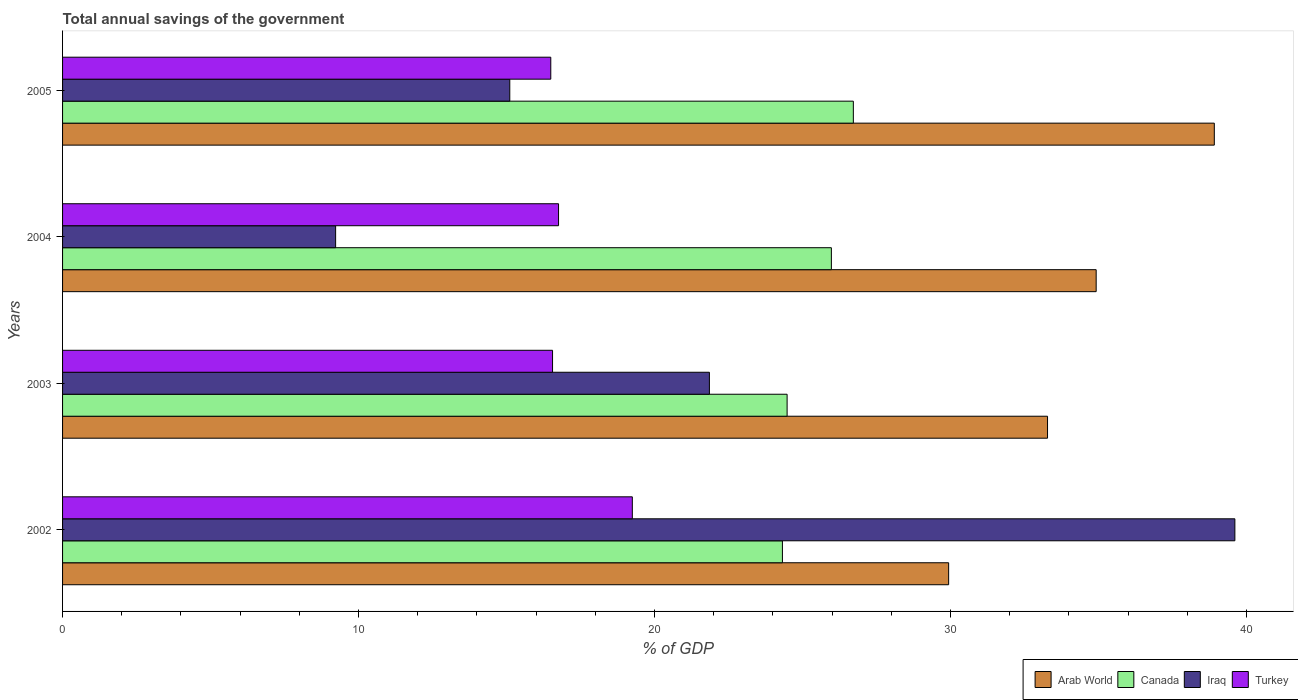How many bars are there on the 2nd tick from the bottom?
Keep it short and to the point. 4. What is the label of the 2nd group of bars from the top?
Your response must be concise. 2004. In how many cases, is the number of bars for a given year not equal to the number of legend labels?
Your response must be concise. 0. What is the total annual savings of the government in Iraq in 2005?
Provide a succinct answer. 15.11. Across all years, what is the maximum total annual savings of the government in Turkey?
Keep it short and to the point. 19.25. Across all years, what is the minimum total annual savings of the government in Iraq?
Ensure brevity in your answer.  9.22. In which year was the total annual savings of the government in Arab World maximum?
Your answer should be compact. 2005. In which year was the total annual savings of the government in Arab World minimum?
Make the answer very short. 2002. What is the total total annual savings of the government in Arab World in the graph?
Make the answer very short. 137.04. What is the difference between the total annual savings of the government in Iraq in 2004 and that in 2005?
Provide a succinct answer. -5.88. What is the difference between the total annual savings of the government in Canada in 2003 and the total annual savings of the government in Turkey in 2002?
Your response must be concise. 5.23. What is the average total annual savings of the government in Turkey per year?
Give a very brief answer. 17.26. In the year 2005, what is the difference between the total annual savings of the government in Arab World and total annual savings of the government in Canada?
Keep it short and to the point. 12.19. What is the ratio of the total annual savings of the government in Canada in 2002 to that in 2005?
Offer a terse response. 0.91. What is the difference between the highest and the second highest total annual savings of the government in Turkey?
Keep it short and to the point. 2.49. What is the difference between the highest and the lowest total annual savings of the government in Canada?
Your answer should be very brief. 2.4. In how many years, is the total annual savings of the government in Canada greater than the average total annual savings of the government in Canada taken over all years?
Provide a short and direct response. 2. Is the sum of the total annual savings of the government in Canada in 2003 and 2005 greater than the maximum total annual savings of the government in Turkey across all years?
Your response must be concise. Yes. Is it the case that in every year, the sum of the total annual savings of the government in Canada and total annual savings of the government in Iraq is greater than the sum of total annual savings of the government in Turkey and total annual savings of the government in Arab World?
Ensure brevity in your answer.  No. What does the 4th bar from the top in 2005 represents?
Offer a very short reply. Arab World. What does the 1st bar from the bottom in 2004 represents?
Your response must be concise. Arab World. Is it the case that in every year, the sum of the total annual savings of the government in Iraq and total annual savings of the government in Canada is greater than the total annual savings of the government in Arab World?
Keep it short and to the point. Yes. How many bars are there?
Offer a very short reply. 16. How many years are there in the graph?
Offer a terse response. 4. Are the values on the major ticks of X-axis written in scientific E-notation?
Make the answer very short. No. Does the graph contain any zero values?
Your response must be concise. No. Does the graph contain grids?
Your answer should be very brief. No. Where does the legend appear in the graph?
Make the answer very short. Bottom right. How many legend labels are there?
Your response must be concise. 4. What is the title of the graph?
Provide a succinct answer. Total annual savings of the government. What is the label or title of the X-axis?
Your response must be concise. % of GDP. What is the % of GDP of Arab World in 2002?
Your response must be concise. 29.93. What is the % of GDP in Canada in 2002?
Ensure brevity in your answer.  24.32. What is the % of GDP in Iraq in 2002?
Your answer should be compact. 39.6. What is the % of GDP of Turkey in 2002?
Make the answer very short. 19.25. What is the % of GDP in Arab World in 2003?
Your answer should be very brief. 33.28. What is the % of GDP in Canada in 2003?
Offer a terse response. 24.48. What is the % of GDP of Iraq in 2003?
Give a very brief answer. 21.85. What is the % of GDP of Turkey in 2003?
Make the answer very short. 16.55. What is the % of GDP of Arab World in 2004?
Keep it short and to the point. 34.92. What is the % of GDP in Canada in 2004?
Keep it short and to the point. 25.97. What is the % of GDP of Iraq in 2004?
Ensure brevity in your answer.  9.22. What is the % of GDP in Turkey in 2004?
Your answer should be very brief. 16.76. What is the % of GDP of Arab World in 2005?
Give a very brief answer. 38.91. What is the % of GDP of Canada in 2005?
Keep it short and to the point. 26.72. What is the % of GDP in Iraq in 2005?
Give a very brief answer. 15.11. What is the % of GDP in Turkey in 2005?
Your answer should be very brief. 16.49. Across all years, what is the maximum % of GDP of Arab World?
Your answer should be very brief. 38.91. Across all years, what is the maximum % of GDP of Canada?
Your response must be concise. 26.72. Across all years, what is the maximum % of GDP of Iraq?
Keep it short and to the point. 39.6. Across all years, what is the maximum % of GDP of Turkey?
Keep it short and to the point. 19.25. Across all years, what is the minimum % of GDP in Arab World?
Make the answer very short. 29.93. Across all years, what is the minimum % of GDP in Canada?
Your answer should be compact. 24.32. Across all years, what is the minimum % of GDP of Iraq?
Your response must be concise. 9.22. Across all years, what is the minimum % of GDP in Turkey?
Make the answer very short. 16.49. What is the total % of GDP in Arab World in the graph?
Your response must be concise. 137.04. What is the total % of GDP in Canada in the graph?
Provide a succinct answer. 101.49. What is the total % of GDP of Iraq in the graph?
Provide a succinct answer. 85.79. What is the total % of GDP of Turkey in the graph?
Your response must be concise. 69.05. What is the difference between the % of GDP of Arab World in 2002 and that in 2003?
Your answer should be compact. -3.34. What is the difference between the % of GDP in Canada in 2002 and that in 2003?
Provide a succinct answer. -0.16. What is the difference between the % of GDP of Iraq in 2002 and that in 2003?
Your response must be concise. 17.75. What is the difference between the % of GDP in Turkey in 2002 and that in 2003?
Give a very brief answer. 2.7. What is the difference between the % of GDP in Arab World in 2002 and that in 2004?
Keep it short and to the point. -4.98. What is the difference between the % of GDP in Canada in 2002 and that in 2004?
Provide a short and direct response. -1.65. What is the difference between the % of GDP of Iraq in 2002 and that in 2004?
Your answer should be very brief. 30.38. What is the difference between the % of GDP in Turkey in 2002 and that in 2004?
Your response must be concise. 2.49. What is the difference between the % of GDP of Arab World in 2002 and that in 2005?
Offer a terse response. -8.98. What is the difference between the % of GDP of Canada in 2002 and that in 2005?
Offer a terse response. -2.4. What is the difference between the % of GDP of Iraq in 2002 and that in 2005?
Your answer should be very brief. 24.5. What is the difference between the % of GDP in Turkey in 2002 and that in 2005?
Give a very brief answer. 2.76. What is the difference between the % of GDP of Arab World in 2003 and that in 2004?
Provide a short and direct response. -1.64. What is the difference between the % of GDP of Canada in 2003 and that in 2004?
Ensure brevity in your answer.  -1.5. What is the difference between the % of GDP in Iraq in 2003 and that in 2004?
Your response must be concise. 12.63. What is the difference between the % of GDP of Turkey in 2003 and that in 2004?
Keep it short and to the point. -0.2. What is the difference between the % of GDP in Arab World in 2003 and that in 2005?
Provide a succinct answer. -5.63. What is the difference between the % of GDP of Canada in 2003 and that in 2005?
Give a very brief answer. -2.24. What is the difference between the % of GDP in Iraq in 2003 and that in 2005?
Make the answer very short. 6.74. What is the difference between the % of GDP of Turkey in 2003 and that in 2005?
Offer a terse response. 0.06. What is the difference between the % of GDP of Arab World in 2004 and that in 2005?
Offer a very short reply. -3.99. What is the difference between the % of GDP of Canada in 2004 and that in 2005?
Offer a terse response. -0.74. What is the difference between the % of GDP in Iraq in 2004 and that in 2005?
Give a very brief answer. -5.88. What is the difference between the % of GDP of Turkey in 2004 and that in 2005?
Ensure brevity in your answer.  0.26. What is the difference between the % of GDP of Arab World in 2002 and the % of GDP of Canada in 2003?
Your answer should be very brief. 5.46. What is the difference between the % of GDP in Arab World in 2002 and the % of GDP in Iraq in 2003?
Give a very brief answer. 8.08. What is the difference between the % of GDP of Arab World in 2002 and the % of GDP of Turkey in 2003?
Your answer should be very brief. 13.38. What is the difference between the % of GDP in Canada in 2002 and the % of GDP in Iraq in 2003?
Your response must be concise. 2.47. What is the difference between the % of GDP in Canada in 2002 and the % of GDP in Turkey in 2003?
Your answer should be very brief. 7.77. What is the difference between the % of GDP in Iraq in 2002 and the % of GDP in Turkey in 2003?
Give a very brief answer. 23.05. What is the difference between the % of GDP in Arab World in 2002 and the % of GDP in Canada in 2004?
Make the answer very short. 3.96. What is the difference between the % of GDP in Arab World in 2002 and the % of GDP in Iraq in 2004?
Keep it short and to the point. 20.71. What is the difference between the % of GDP of Arab World in 2002 and the % of GDP of Turkey in 2004?
Your answer should be compact. 13.18. What is the difference between the % of GDP of Canada in 2002 and the % of GDP of Iraq in 2004?
Make the answer very short. 15.09. What is the difference between the % of GDP in Canada in 2002 and the % of GDP in Turkey in 2004?
Offer a terse response. 7.56. What is the difference between the % of GDP in Iraq in 2002 and the % of GDP in Turkey in 2004?
Offer a very short reply. 22.85. What is the difference between the % of GDP of Arab World in 2002 and the % of GDP of Canada in 2005?
Your answer should be very brief. 3.22. What is the difference between the % of GDP of Arab World in 2002 and the % of GDP of Iraq in 2005?
Your answer should be very brief. 14.83. What is the difference between the % of GDP of Arab World in 2002 and the % of GDP of Turkey in 2005?
Make the answer very short. 13.44. What is the difference between the % of GDP of Canada in 2002 and the % of GDP of Iraq in 2005?
Your response must be concise. 9.21. What is the difference between the % of GDP of Canada in 2002 and the % of GDP of Turkey in 2005?
Offer a terse response. 7.83. What is the difference between the % of GDP in Iraq in 2002 and the % of GDP in Turkey in 2005?
Offer a very short reply. 23.11. What is the difference between the % of GDP of Arab World in 2003 and the % of GDP of Canada in 2004?
Make the answer very short. 7.3. What is the difference between the % of GDP in Arab World in 2003 and the % of GDP in Iraq in 2004?
Offer a terse response. 24.05. What is the difference between the % of GDP in Arab World in 2003 and the % of GDP in Turkey in 2004?
Offer a terse response. 16.52. What is the difference between the % of GDP in Canada in 2003 and the % of GDP in Iraq in 2004?
Your answer should be compact. 15.25. What is the difference between the % of GDP of Canada in 2003 and the % of GDP of Turkey in 2004?
Make the answer very short. 7.72. What is the difference between the % of GDP in Iraq in 2003 and the % of GDP in Turkey in 2004?
Make the answer very short. 5.1. What is the difference between the % of GDP of Arab World in 2003 and the % of GDP of Canada in 2005?
Offer a very short reply. 6.56. What is the difference between the % of GDP of Arab World in 2003 and the % of GDP of Iraq in 2005?
Keep it short and to the point. 18.17. What is the difference between the % of GDP in Arab World in 2003 and the % of GDP in Turkey in 2005?
Your answer should be compact. 16.78. What is the difference between the % of GDP in Canada in 2003 and the % of GDP in Iraq in 2005?
Make the answer very short. 9.37. What is the difference between the % of GDP of Canada in 2003 and the % of GDP of Turkey in 2005?
Your answer should be compact. 7.98. What is the difference between the % of GDP of Iraq in 2003 and the % of GDP of Turkey in 2005?
Keep it short and to the point. 5.36. What is the difference between the % of GDP of Arab World in 2004 and the % of GDP of Canada in 2005?
Give a very brief answer. 8.2. What is the difference between the % of GDP of Arab World in 2004 and the % of GDP of Iraq in 2005?
Provide a short and direct response. 19.81. What is the difference between the % of GDP of Arab World in 2004 and the % of GDP of Turkey in 2005?
Provide a short and direct response. 18.43. What is the difference between the % of GDP of Canada in 2004 and the % of GDP of Iraq in 2005?
Your answer should be compact. 10.86. What is the difference between the % of GDP of Canada in 2004 and the % of GDP of Turkey in 2005?
Provide a succinct answer. 9.48. What is the difference between the % of GDP in Iraq in 2004 and the % of GDP in Turkey in 2005?
Keep it short and to the point. -7.27. What is the average % of GDP of Arab World per year?
Ensure brevity in your answer.  34.26. What is the average % of GDP of Canada per year?
Your answer should be compact. 25.37. What is the average % of GDP of Iraq per year?
Make the answer very short. 21.45. What is the average % of GDP in Turkey per year?
Your answer should be very brief. 17.26. In the year 2002, what is the difference between the % of GDP in Arab World and % of GDP in Canada?
Your answer should be compact. 5.62. In the year 2002, what is the difference between the % of GDP of Arab World and % of GDP of Iraq?
Your response must be concise. -9.67. In the year 2002, what is the difference between the % of GDP in Arab World and % of GDP in Turkey?
Provide a succinct answer. 10.69. In the year 2002, what is the difference between the % of GDP in Canada and % of GDP in Iraq?
Your response must be concise. -15.29. In the year 2002, what is the difference between the % of GDP of Canada and % of GDP of Turkey?
Your answer should be very brief. 5.07. In the year 2002, what is the difference between the % of GDP in Iraq and % of GDP in Turkey?
Your response must be concise. 20.36. In the year 2003, what is the difference between the % of GDP of Arab World and % of GDP of Canada?
Ensure brevity in your answer.  8.8. In the year 2003, what is the difference between the % of GDP in Arab World and % of GDP in Iraq?
Offer a terse response. 11.42. In the year 2003, what is the difference between the % of GDP in Arab World and % of GDP in Turkey?
Offer a very short reply. 16.72. In the year 2003, what is the difference between the % of GDP in Canada and % of GDP in Iraq?
Make the answer very short. 2.63. In the year 2003, what is the difference between the % of GDP in Canada and % of GDP in Turkey?
Make the answer very short. 7.92. In the year 2003, what is the difference between the % of GDP in Iraq and % of GDP in Turkey?
Your response must be concise. 5.3. In the year 2004, what is the difference between the % of GDP in Arab World and % of GDP in Canada?
Give a very brief answer. 8.95. In the year 2004, what is the difference between the % of GDP of Arab World and % of GDP of Iraq?
Provide a short and direct response. 25.69. In the year 2004, what is the difference between the % of GDP in Arab World and % of GDP in Turkey?
Give a very brief answer. 18.16. In the year 2004, what is the difference between the % of GDP in Canada and % of GDP in Iraq?
Give a very brief answer. 16.75. In the year 2004, what is the difference between the % of GDP in Canada and % of GDP in Turkey?
Make the answer very short. 9.22. In the year 2004, what is the difference between the % of GDP in Iraq and % of GDP in Turkey?
Your answer should be compact. -7.53. In the year 2005, what is the difference between the % of GDP in Arab World and % of GDP in Canada?
Your response must be concise. 12.19. In the year 2005, what is the difference between the % of GDP in Arab World and % of GDP in Iraq?
Your answer should be compact. 23.8. In the year 2005, what is the difference between the % of GDP of Arab World and % of GDP of Turkey?
Provide a succinct answer. 22.42. In the year 2005, what is the difference between the % of GDP of Canada and % of GDP of Iraq?
Offer a terse response. 11.61. In the year 2005, what is the difference between the % of GDP in Canada and % of GDP in Turkey?
Offer a very short reply. 10.22. In the year 2005, what is the difference between the % of GDP of Iraq and % of GDP of Turkey?
Give a very brief answer. -1.39. What is the ratio of the % of GDP of Arab World in 2002 to that in 2003?
Offer a very short reply. 0.9. What is the ratio of the % of GDP of Iraq in 2002 to that in 2003?
Your answer should be compact. 1.81. What is the ratio of the % of GDP in Turkey in 2002 to that in 2003?
Offer a very short reply. 1.16. What is the ratio of the % of GDP of Arab World in 2002 to that in 2004?
Your answer should be compact. 0.86. What is the ratio of the % of GDP in Canada in 2002 to that in 2004?
Your answer should be very brief. 0.94. What is the ratio of the % of GDP in Iraq in 2002 to that in 2004?
Offer a terse response. 4.29. What is the ratio of the % of GDP of Turkey in 2002 to that in 2004?
Your answer should be very brief. 1.15. What is the ratio of the % of GDP in Arab World in 2002 to that in 2005?
Give a very brief answer. 0.77. What is the ratio of the % of GDP in Canada in 2002 to that in 2005?
Make the answer very short. 0.91. What is the ratio of the % of GDP in Iraq in 2002 to that in 2005?
Your response must be concise. 2.62. What is the ratio of the % of GDP of Turkey in 2002 to that in 2005?
Offer a very short reply. 1.17. What is the ratio of the % of GDP in Arab World in 2003 to that in 2004?
Give a very brief answer. 0.95. What is the ratio of the % of GDP of Canada in 2003 to that in 2004?
Offer a very short reply. 0.94. What is the ratio of the % of GDP of Iraq in 2003 to that in 2004?
Offer a very short reply. 2.37. What is the ratio of the % of GDP of Turkey in 2003 to that in 2004?
Make the answer very short. 0.99. What is the ratio of the % of GDP in Arab World in 2003 to that in 2005?
Your response must be concise. 0.86. What is the ratio of the % of GDP in Canada in 2003 to that in 2005?
Your answer should be very brief. 0.92. What is the ratio of the % of GDP of Iraq in 2003 to that in 2005?
Provide a succinct answer. 1.45. What is the ratio of the % of GDP of Turkey in 2003 to that in 2005?
Make the answer very short. 1. What is the ratio of the % of GDP of Arab World in 2004 to that in 2005?
Provide a short and direct response. 0.9. What is the ratio of the % of GDP of Canada in 2004 to that in 2005?
Your response must be concise. 0.97. What is the ratio of the % of GDP in Iraq in 2004 to that in 2005?
Your answer should be very brief. 0.61. What is the ratio of the % of GDP of Turkey in 2004 to that in 2005?
Offer a very short reply. 1.02. What is the difference between the highest and the second highest % of GDP in Arab World?
Ensure brevity in your answer.  3.99. What is the difference between the highest and the second highest % of GDP of Canada?
Make the answer very short. 0.74. What is the difference between the highest and the second highest % of GDP of Iraq?
Provide a short and direct response. 17.75. What is the difference between the highest and the second highest % of GDP of Turkey?
Keep it short and to the point. 2.49. What is the difference between the highest and the lowest % of GDP of Arab World?
Provide a short and direct response. 8.98. What is the difference between the highest and the lowest % of GDP of Canada?
Give a very brief answer. 2.4. What is the difference between the highest and the lowest % of GDP in Iraq?
Provide a succinct answer. 30.38. What is the difference between the highest and the lowest % of GDP in Turkey?
Provide a short and direct response. 2.76. 